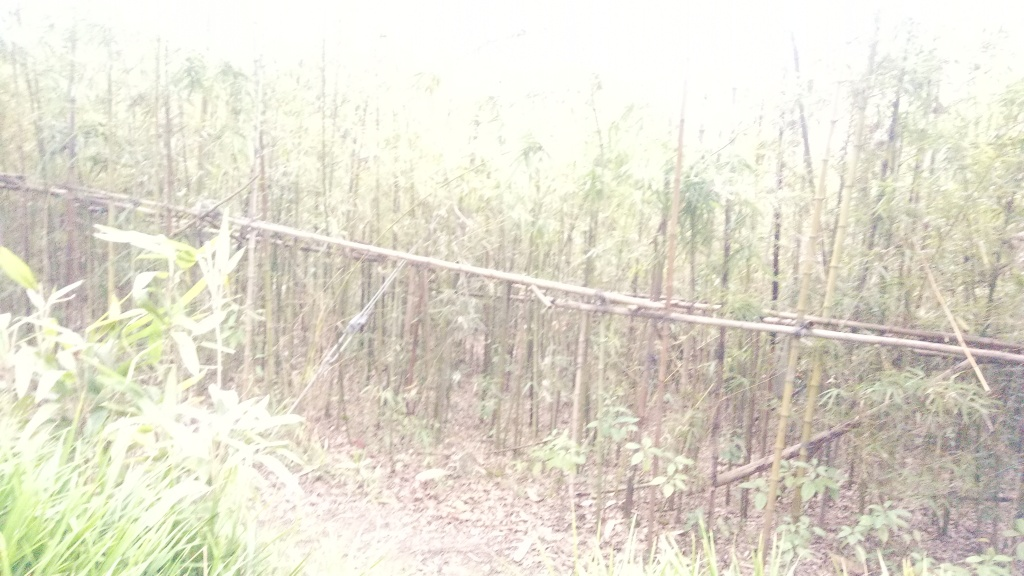What time of day do you think this photo was taken? Given the overall brightness of the image, despite its overexposure, it seems likely that the photo was taken during daylight hours. However, the exact time of day is difficult to ascertain due to the lack of shadows and the white balance issue altering the natural colors. What kind of weather or light conditions might lead to a photo like this? A photo with this kind of overexposure could result from taking a picture directly towards a light source, like the sun, especially in a brightly lit environment. It might also happen in foggy or misty conditions where light is diffused and camera settings are not adjusted properly for the high key lighting scenario. 